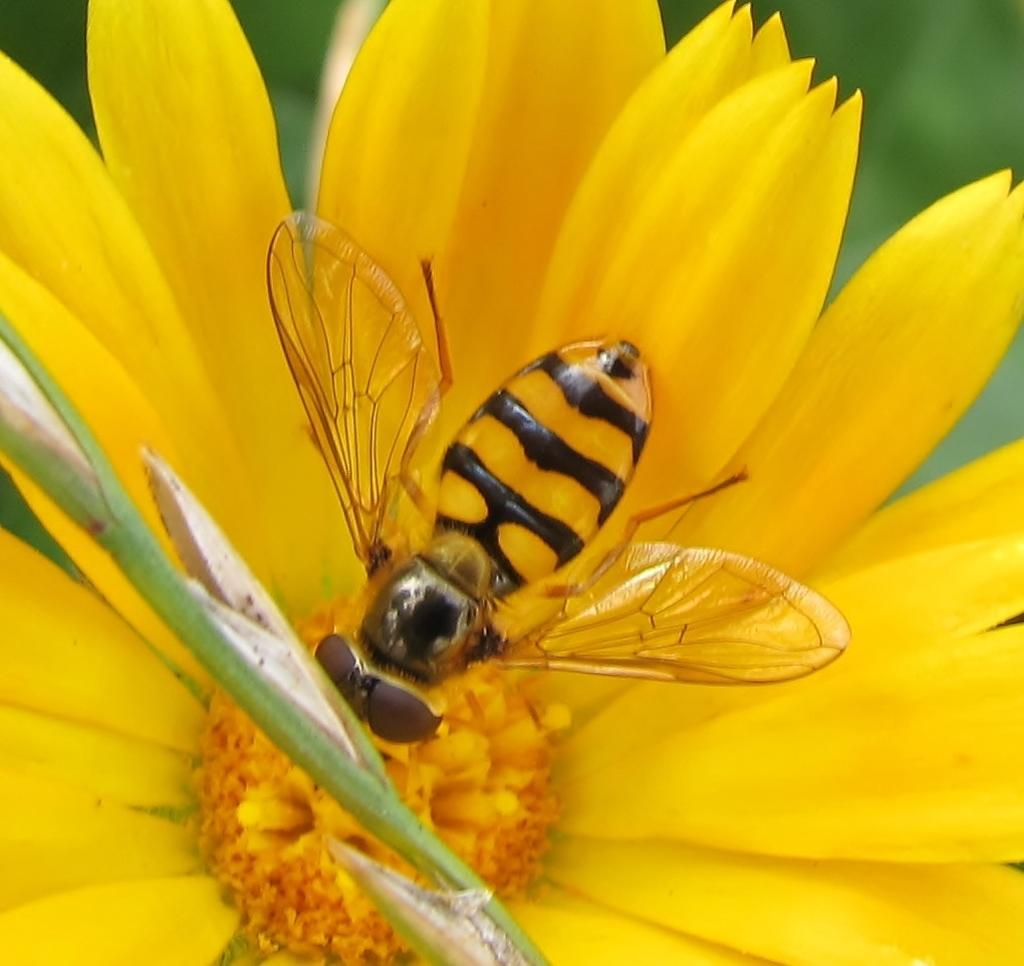What is the main subject of the image? There is a honey bee in the image. Where is the honey bee located in the image? The honey bee is on a flower. Can you describe the background of the image? The background of the image is blurred. What type of laughter can be heard coming from the honey bee in the image? There is no laughter present in the image, as honey bees do not have the ability to laugh. 